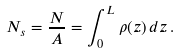<formula> <loc_0><loc_0><loc_500><loc_500>N _ { s } = \frac { N } { A } = \int ^ { L } _ { 0 } \rho ( z ) \, d z \, .</formula> 